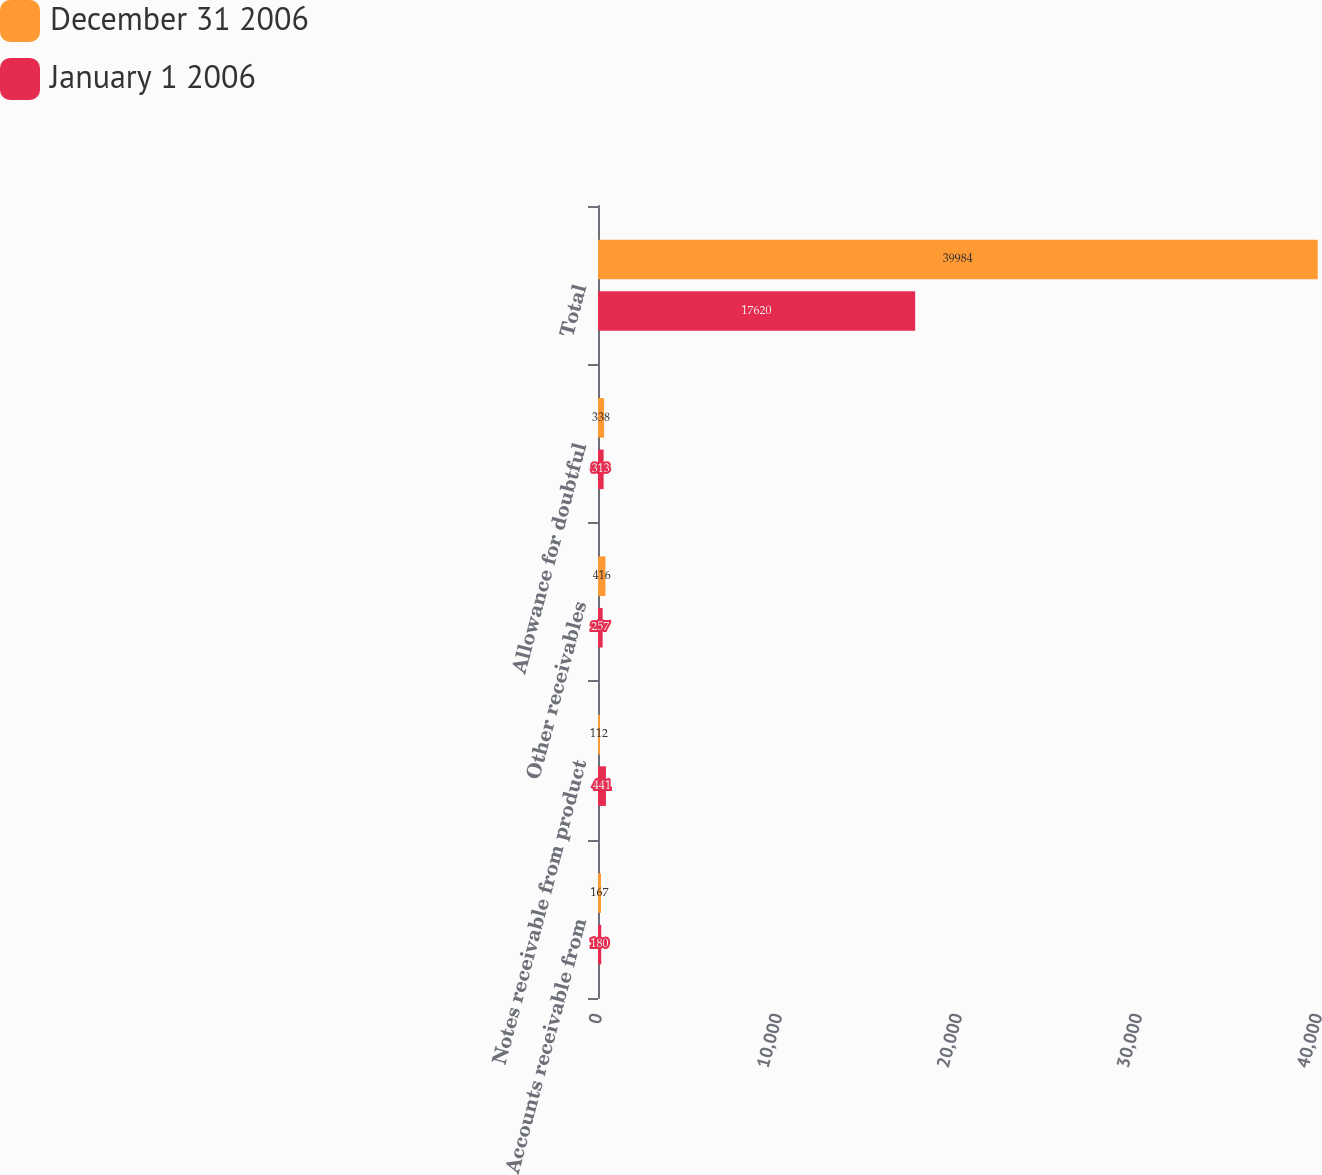Convert chart to OTSL. <chart><loc_0><loc_0><loc_500><loc_500><stacked_bar_chart><ecel><fcel>Accounts receivable from<fcel>Notes receivable from product<fcel>Other receivables<fcel>Allowance for doubtful<fcel>Total<nl><fcel>December 31 2006<fcel>167<fcel>112<fcel>416<fcel>338<fcel>39984<nl><fcel>January 1 2006<fcel>180<fcel>441<fcel>257<fcel>313<fcel>17620<nl></chart> 